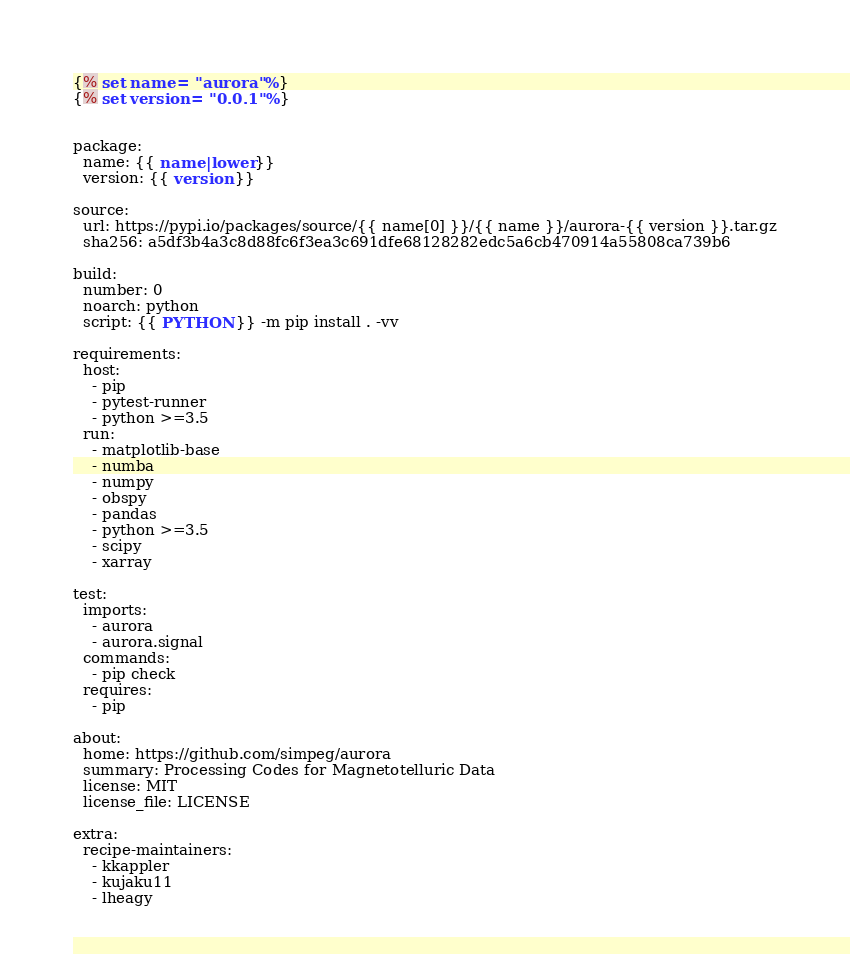<code> <loc_0><loc_0><loc_500><loc_500><_YAML_>{% set name = "aurora" %}
{% set version = "0.0.1" %}


package:
  name: {{ name|lower }}
  version: {{ version }}

source:
  url: https://pypi.io/packages/source/{{ name[0] }}/{{ name }}/aurora-{{ version }}.tar.gz
  sha256: a5df3b4a3c8d88fc6f3ea3c691dfe68128282edc5a6cb470914a55808ca739b6

build:
  number: 0
  noarch: python
  script: {{ PYTHON }} -m pip install . -vv

requirements:
  host:
    - pip
    - pytest-runner
    - python >=3.5
  run:
    - matplotlib-base
    - numba
    - numpy
    - obspy
    - pandas
    - python >=3.5
    - scipy
    - xarray

test:
  imports:
    - aurora
    - aurora.signal
  commands:
    - pip check
  requires:
    - pip

about:
  home: https://github.com/simpeg/aurora
  summary: Processing Codes for Magnetotelluric Data
  license: MIT
  license_file: LICENSE

extra:
  recipe-maintainers:
    - kkappler
    - kujaku11
    - lheagy
</code> 